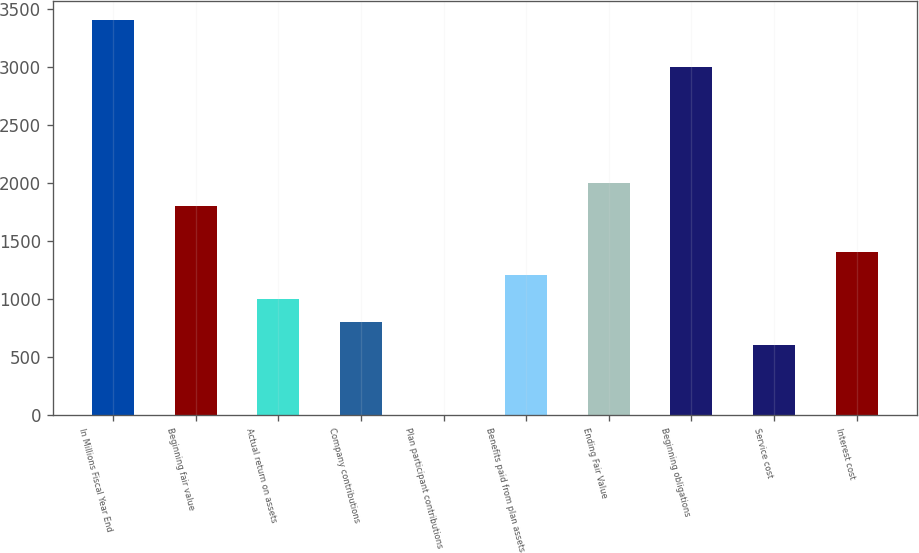<chart> <loc_0><loc_0><loc_500><loc_500><bar_chart><fcel>In Millions Fiscal Year End<fcel>Beginning fair value<fcel>Actual return on assets<fcel>Company contributions<fcel>Plan participant contributions<fcel>Benefits paid from plan assets<fcel>Ending Fair Value<fcel>Beginning obligations<fcel>Service cost<fcel>Interest cost<nl><fcel>3401.2<fcel>1804.4<fcel>1006<fcel>806.4<fcel>8<fcel>1205.6<fcel>2004<fcel>3002<fcel>606.8<fcel>1405.2<nl></chart> 